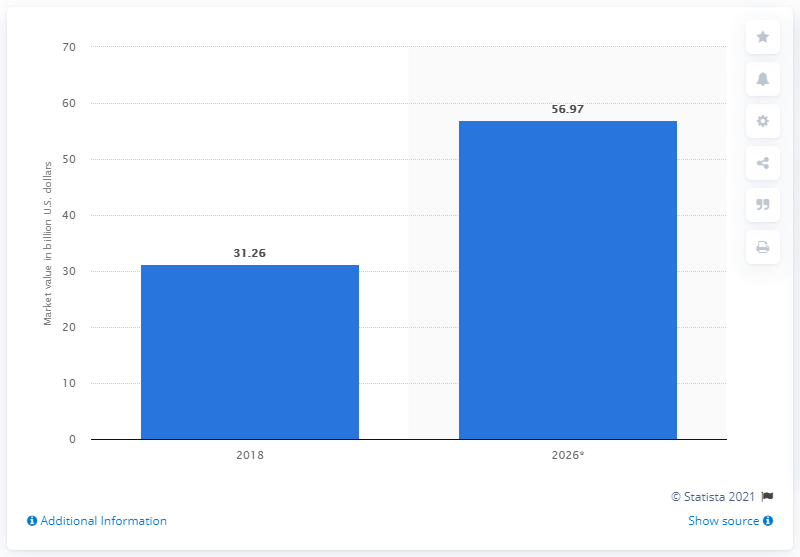Indicate a few pertinent items in this graphic. By 2026, the estimated value of the offshore drilling market is projected to be $56.97 billion. 